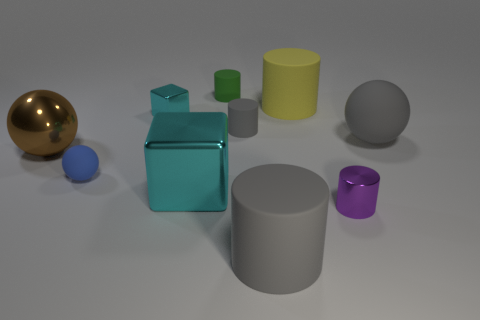What time of day does the lighting in this image suggest? The lighting in the image appears neutral and diffused, with soft shadows indicating an overcast sky or indoor lighting without a strong directional source. It doesn't strongly suggest a particular time of day but rather controlled lighting conditions. 